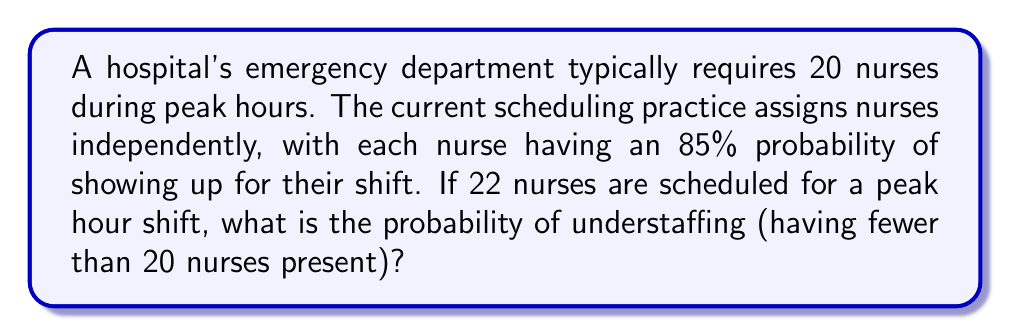Help me with this question. Let's approach this step-by-step:

1) This scenario follows a binomial distribution, where:
   $n = 22$ (number of nurses scheduled)
   $p = 0.85$ (probability of each nurse showing up)
   $X$ = number of nurses who show up

2) We need to find $P(X < 20)$, which is equivalent to $P(X \leq 19)$

3) Using the binomial probability formula:

   $$P(X = k) = \binom{n}{k} p^k (1-p)^{n-k}$$

4) We need to sum this for $k = 0$ to $19$:

   $$P(X \leq 19) = \sum_{k=0}^{19} \binom{22}{k} (0.85)^k (0.15)^{22-k}$$

5) This sum is computationally intensive, so we can use the cumulative binomial probability function or a statistical software.

6) Using a calculator or software, we find:

   $$P(X \leq 19) \approx 0.0404$$

7) Therefore, the probability of understaffing is approximately 0.0404 or 4.04%.
Answer: 0.0404 (or 4.04%) 